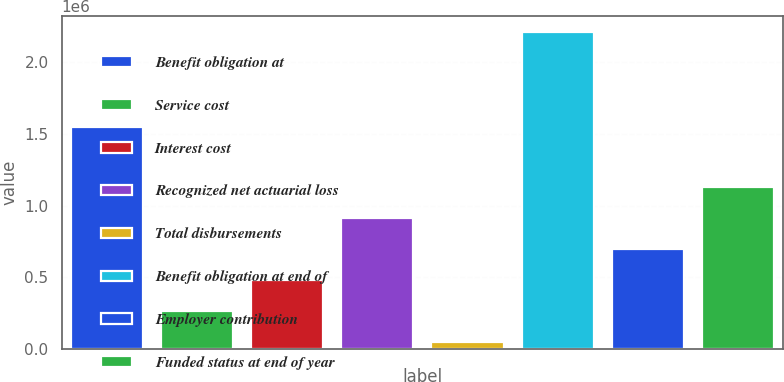Convert chart. <chart><loc_0><loc_0><loc_500><loc_500><bar_chart><fcel>Benefit obligation at<fcel>Service cost<fcel>Interest cost<fcel>Recognized net actuarial loss<fcel>Total disbursements<fcel>Benefit obligation at end of<fcel>Employer contribution<fcel>Funded status at end of year<nl><fcel>1.55194e+06<fcel>265614<fcel>481913<fcel>914511<fcel>49315<fcel>2.2123e+06<fcel>698212<fcel>1.13081e+06<nl></chart> 